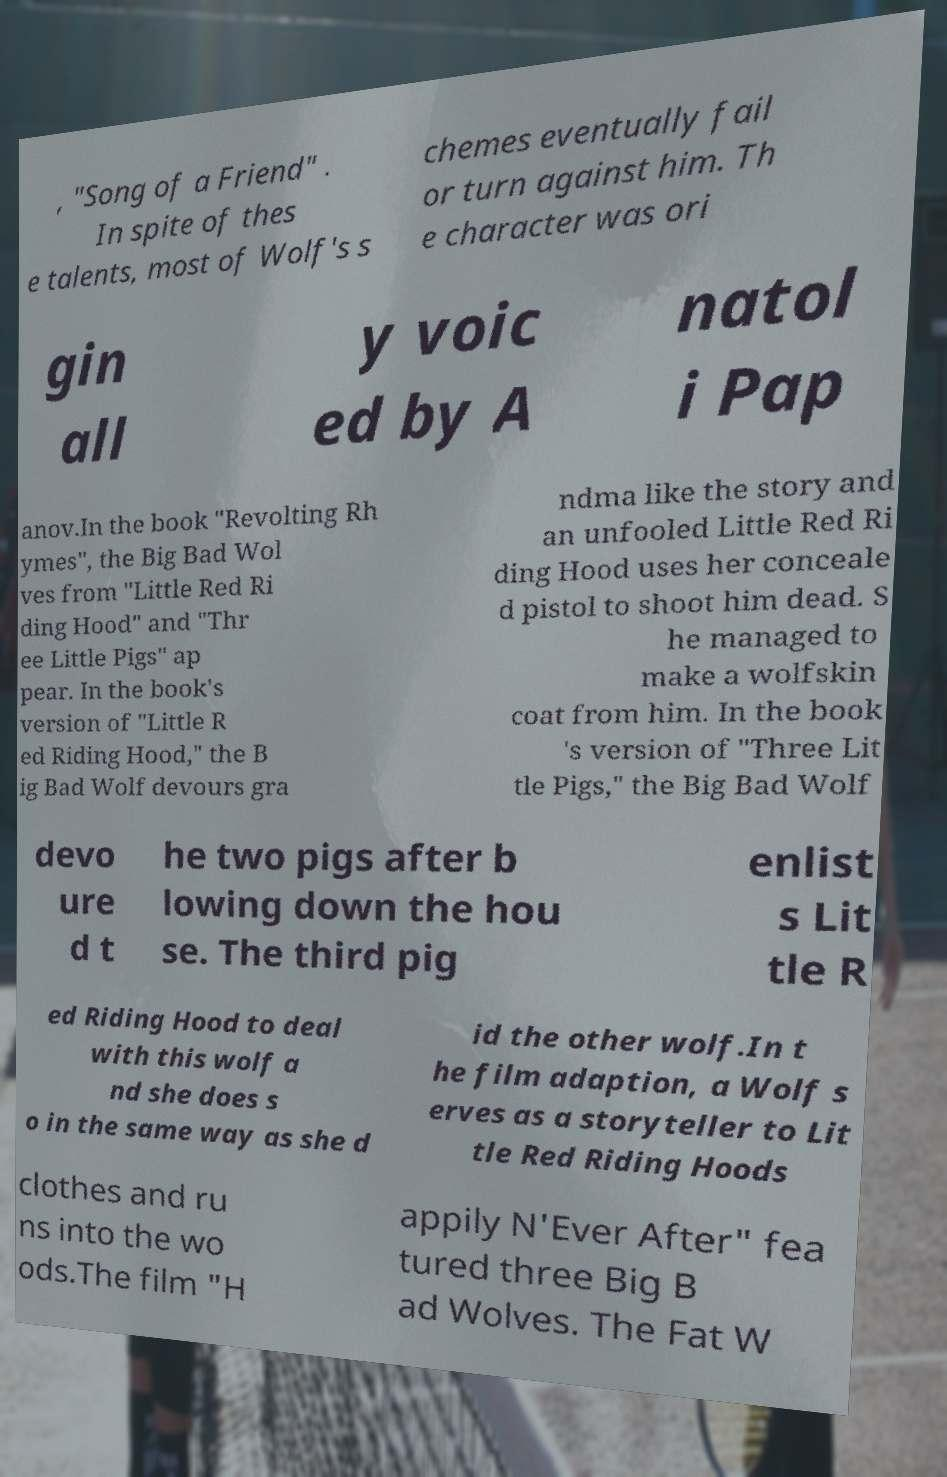Could you extract and type out the text from this image? , "Song of a Friend" . In spite of thes e talents, most of Wolf's s chemes eventually fail or turn against him. Th e character was ori gin all y voic ed by A natol i Pap anov.In the book "Revolting Rh ymes", the Big Bad Wol ves from "Little Red Ri ding Hood" and "Thr ee Little Pigs" ap pear. In the book's version of "Little R ed Riding Hood," the B ig Bad Wolf devours gra ndma like the story and an unfooled Little Red Ri ding Hood uses her conceale d pistol to shoot him dead. S he managed to make a wolfskin coat from him. In the book 's version of "Three Lit tle Pigs," the Big Bad Wolf devo ure d t he two pigs after b lowing down the hou se. The third pig enlist s Lit tle R ed Riding Hood to deal with this wolf a nd she does s o in the same way as she d id the other wolf.In t he film adaption, a Wolf s erves as a storyteller to Lit tle Red Riding Hoods clothes and ru ns into the wo ods.The film "H appily N'Ever After" fea tured three Big B ad Wolves. The Fat W 